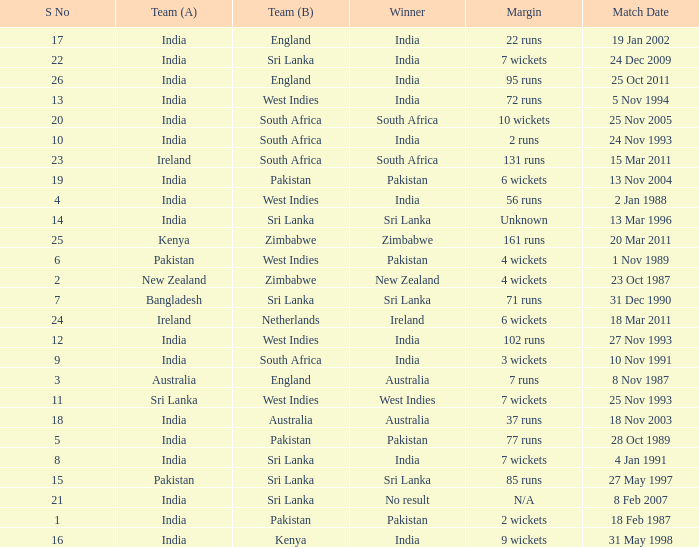How many games were won by a margin of 131 runs? 1.0. 